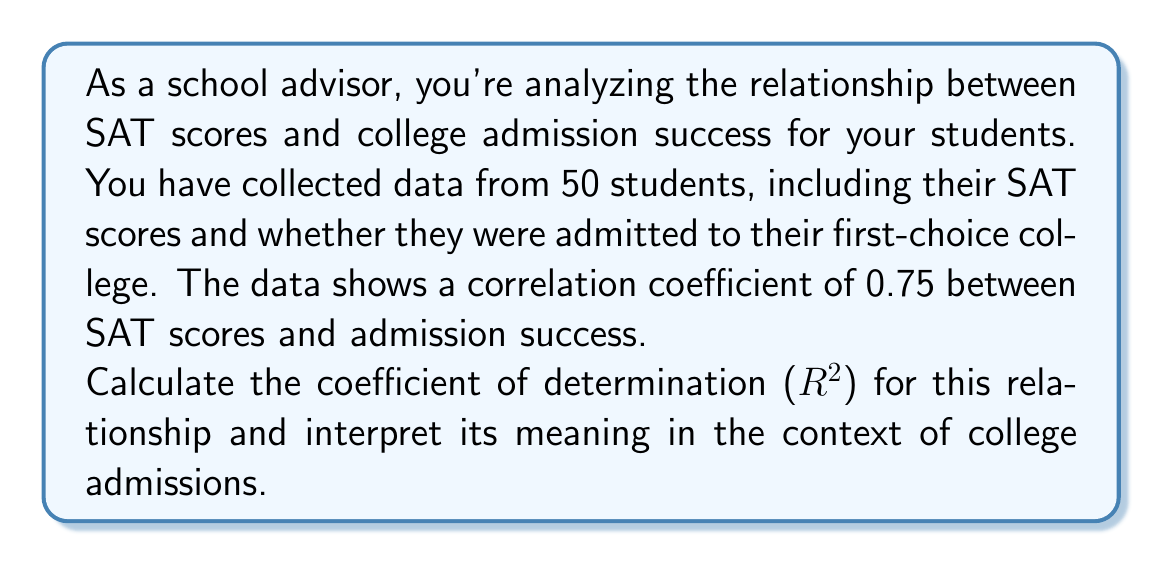Solve this math problem. To solve this problem, we'll follow these steps:

1. Recall the relationship between correlation coefficient (r) and coefficient of determination ($R^2$):
   
   $R^2 = r^2$

2. Calculate $R^2$ using the given correlation coefficient:
   
   $R^2 = (0.75)^2 = 0.5625$

3. Interpret the meaning of $R^2$:

   The coefficient of determination ($R^2$) represents the proportion of variance in the dependent variable (college admission success) that can be explained by the independent variable (SAT scores).

   In this case, $R^2 = 0.5625$ or 56.25%

   This means that approximately 56.25% of the variation in college admission success can be explained by the variation in SAT scores for these students.

Interpretation in the context of college admissions:
- SAT scores account for about 56.25% of the factors influencing college admission success for these students.
- While SAT scores are an important factor, they do not explain all of the variation in admission outcomes. Other factors (such as GPA, extracurricular activities, essays, etc.) likely account for the remaining 43.75% of the variation.
- This information is valuable for a school advisor, as it highlights the importance of SAT scores in the admission process while also emphasizing that other factors play a significant role.
Answer: $R^2 = 0.5625$ or 56.25%

Interpretation: Approximately 56.25% of the variation in college admission success can be explained by SAT scores for these students, indicating that while SAT scores are an important factor, other elements also play a significant role in the admission process. 